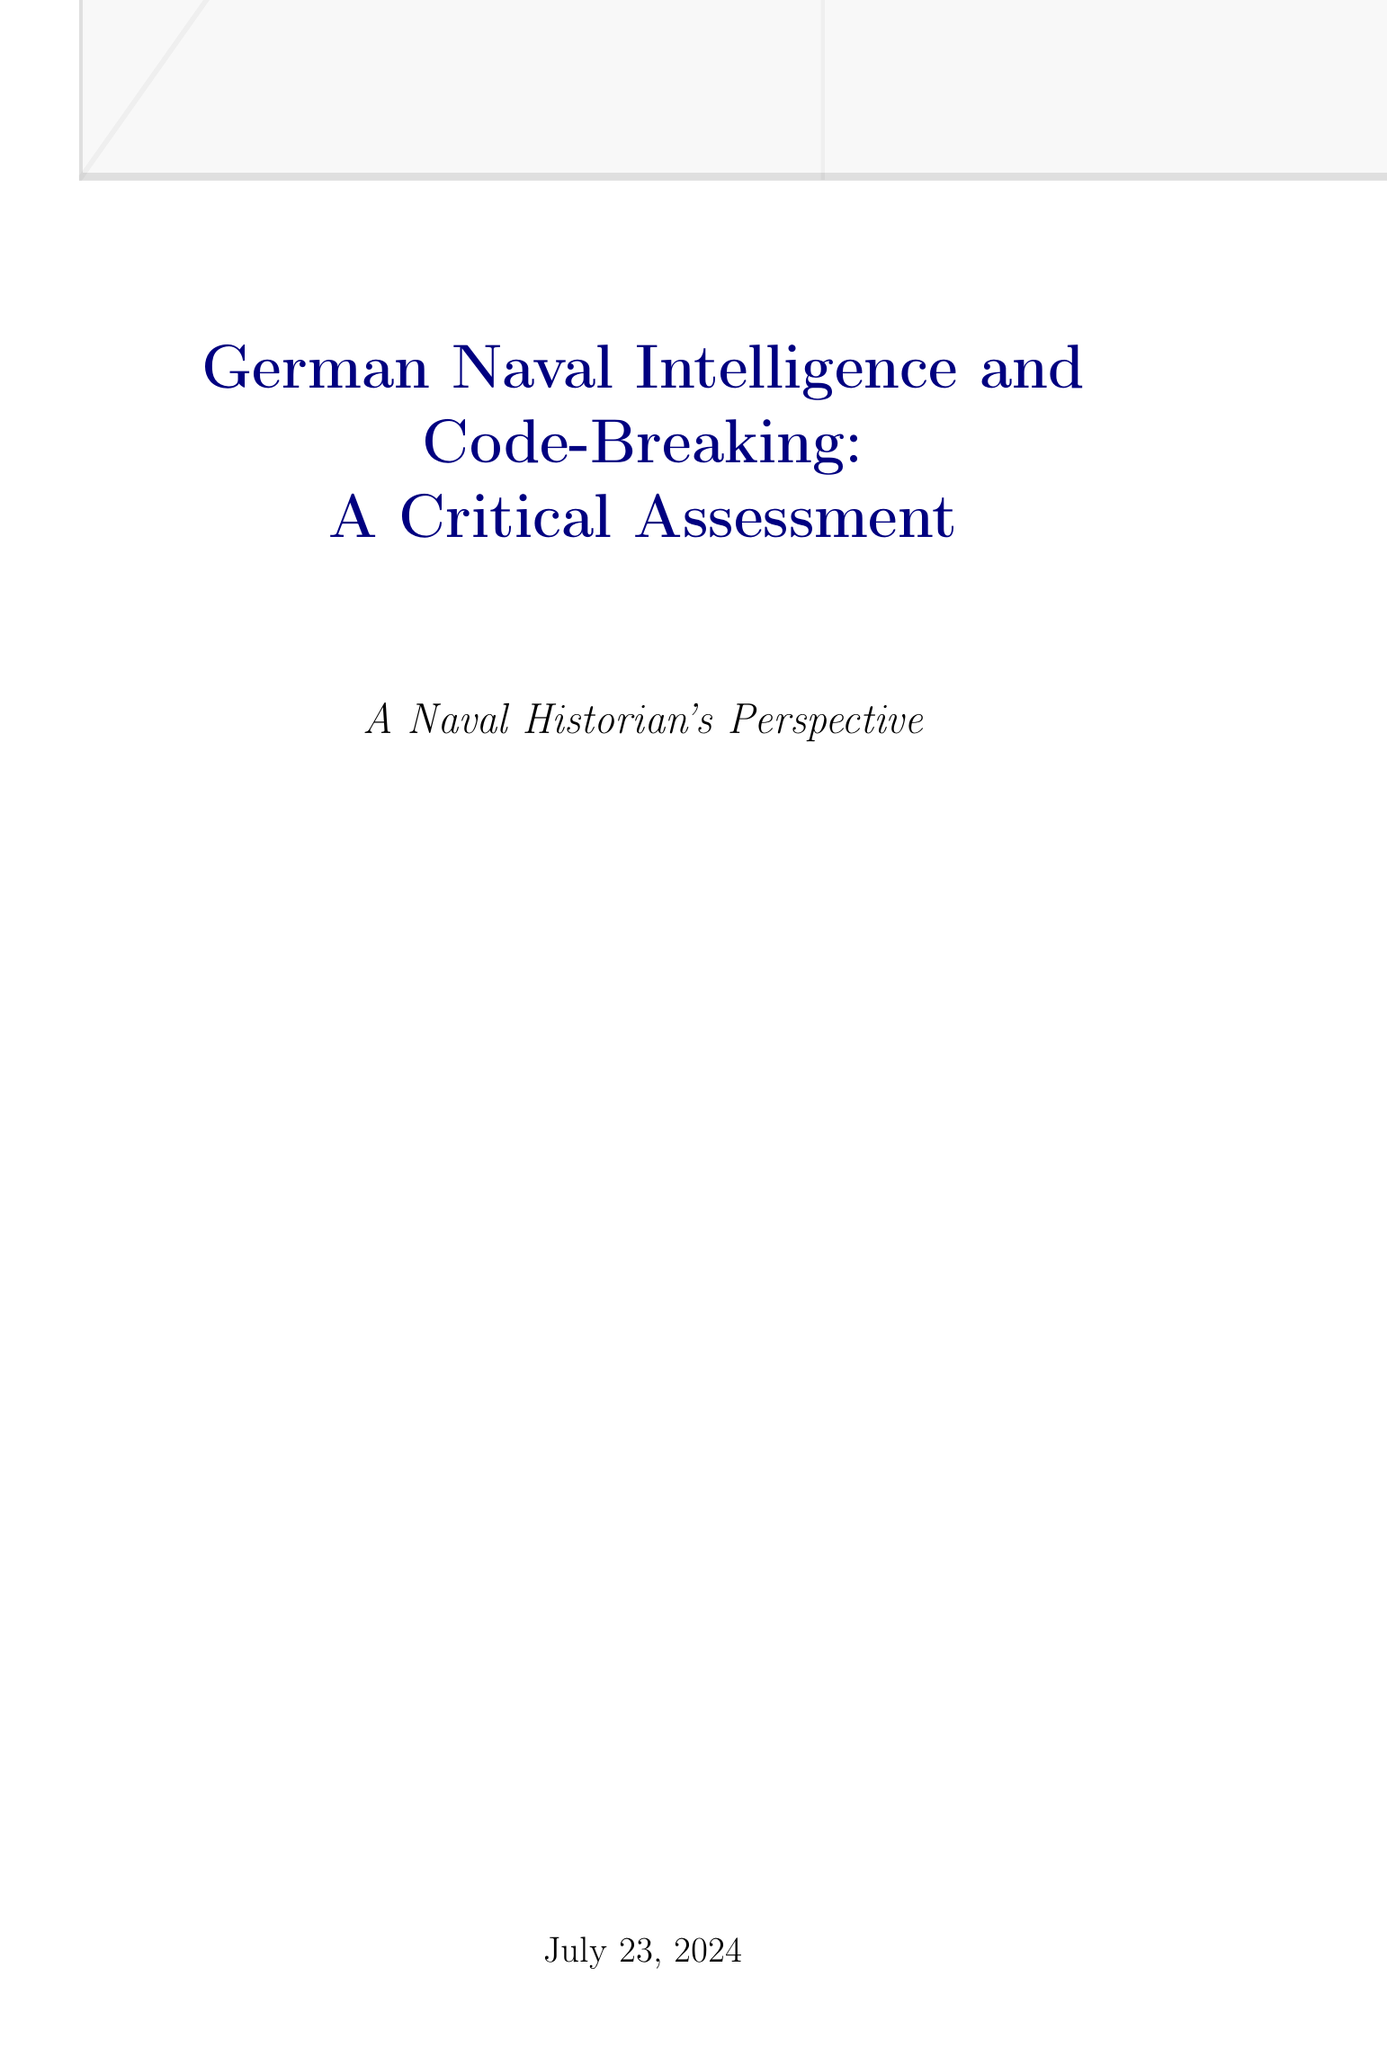What was the British cryptanalysis unit that broke German naval codes? The document mentions that the British cryptanalysis unit, Room 40, successfully broke German naval codes during World War I.
Answer: Room 40 What year was the Beobachtungsdienst (B-Dienst) established? According to the document, the B-Dienst was established in 1925, focusing on intercepting and analyzing foreign naval transmissions.
Answer: 1925 What technology did the German Navy use to locate enemy vessels based on radio transmissions? The document states that German naval intelligence utilized HF/DF techniques, known as 'Huff-Duff', to locate enemy vessels.
Answer: HF/DF Which code did B-Dienst break in 1940? It is indicated in the document that B-Dienst broke the British Naval Cipher No. 3 in 1940, providing valuable intelligence on convoy movements.
Answer: British Naval Cipher No. 3 What was a significant leap in German naval cryptography adopted by the Kriegsmarine in 1926? The document highlights that the adoption of the Enigma machine marked a significant leap in German naval cryptography at that time.
Answer: Enigma machine What was a critical weakness in German naval intelligence during World War II? The document points out that overconfidence in the security of the Enigma system proved to be a critical weakness for German naval intelligence.
Answer: Overconfidence in the Enigma system What was the purpose of the Kurier system developed in 1944? The document states that the Kurier burst transmission system was developed to reduce vulnerability of U-boat communications to Allied interception.
Answer: Reduce vulnerability What impact did the breaking of the Naval Enigma have on the Battle of the Atlantic? The document mentions that the breaking of the Naval Enigma had a significant impact on the Battle of the Atlantic, indicating a strategic disadvantage for the Germans.
Answer: Significant impact What legacy did German naval intelligence operations have post-war? The document concludes by stating that the experiences of German naval intelligence influenced post-war developments in signals intelligence and cryptography.
Answer: Influenced post-war developments 